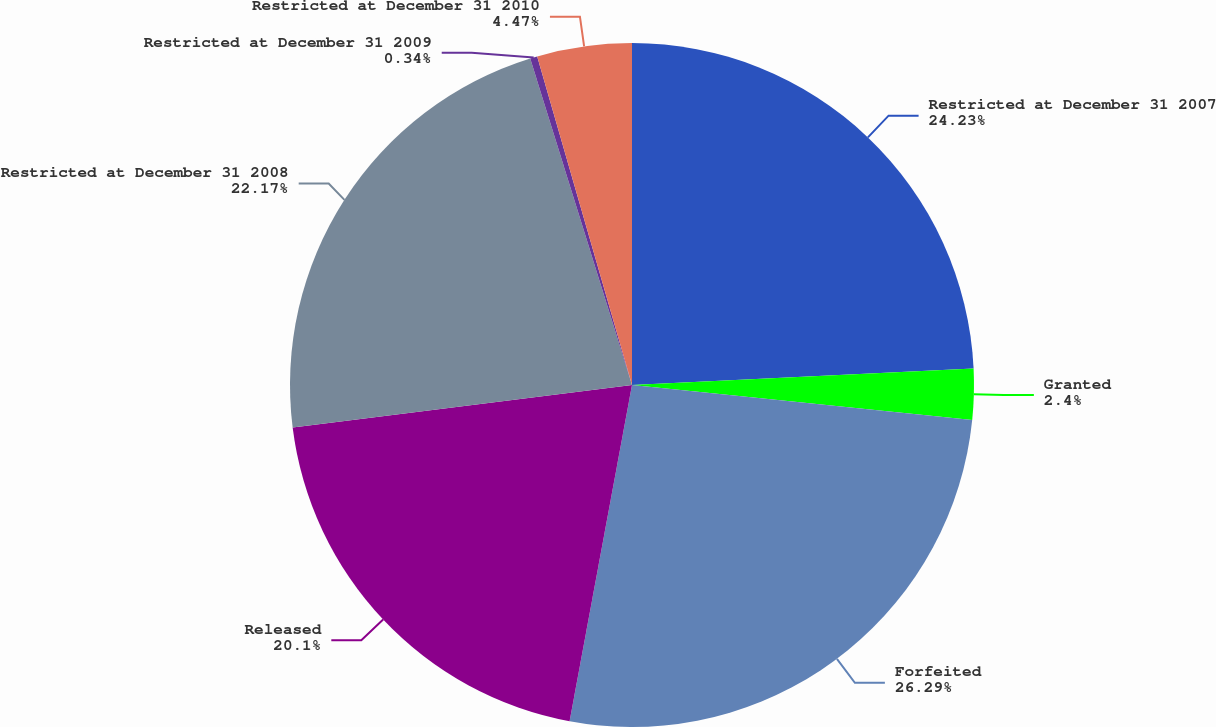Convert chart to OTSL. <chart><loc_0><loc_0><loc_500><loc_500><pie_chart><fcel>Restricted at December 31 2007<fcel>Granted<fcel>Forfeited<fcel>Released<fcel>Restricted at December 31 2008<fcel>Restricted at December 31 2009<fcel>Restricted at December 31 2010<nl><fcel>24.23%<fcel>2.4%<fcel>26.29%<fcel>20.1%<fcel>22.17%<fcel>0.34%<fcel>4.47%<nl></chart> 